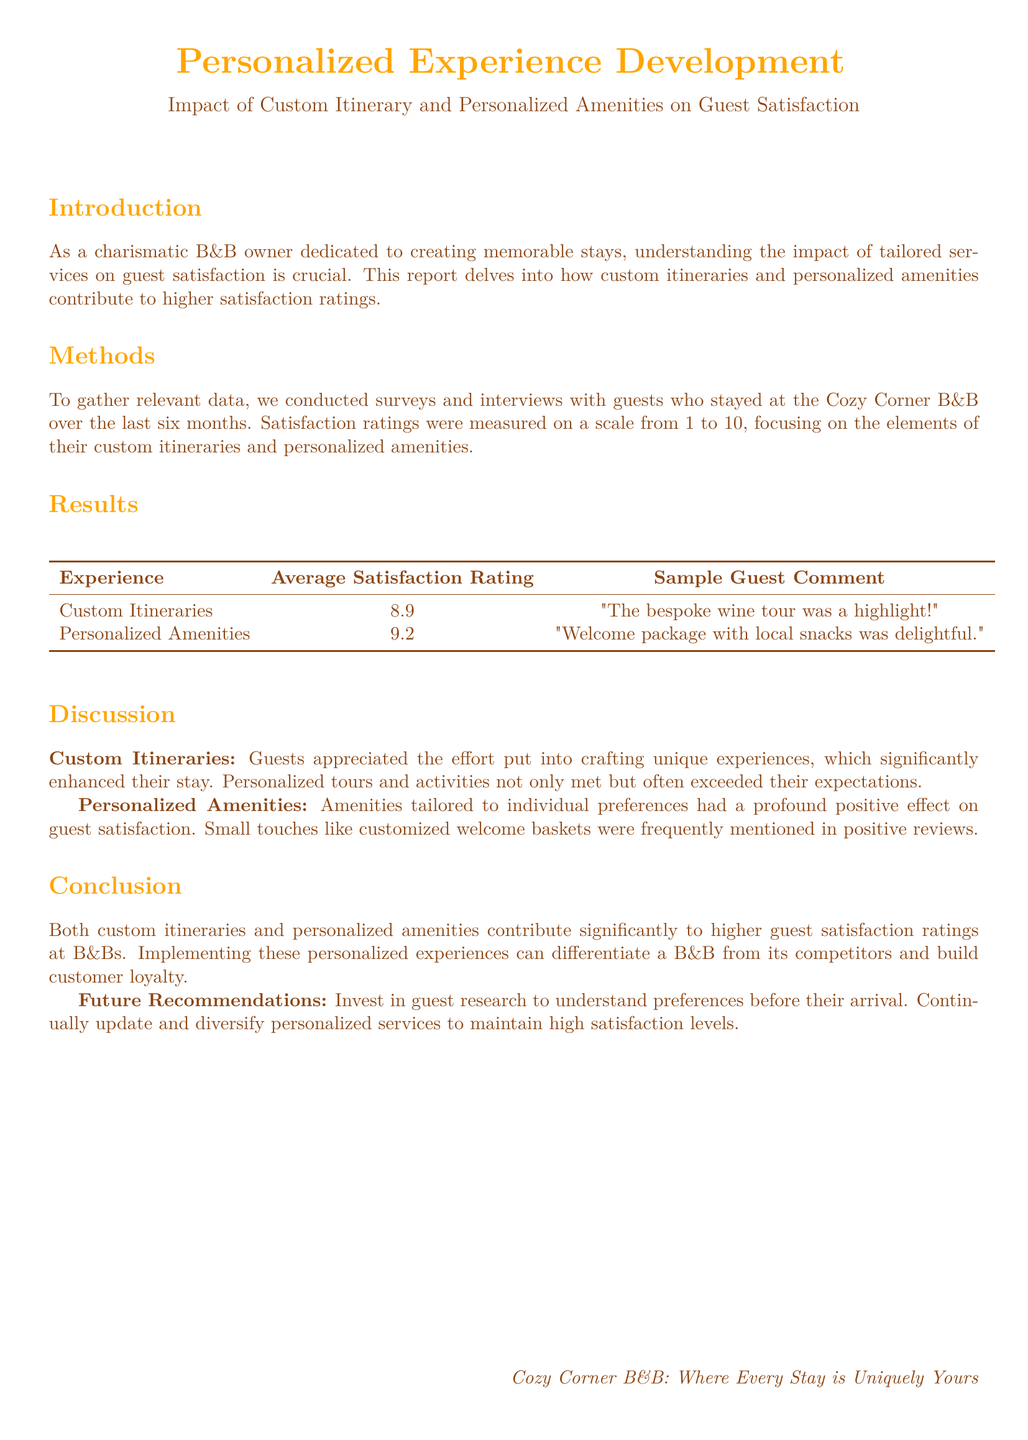What was the average satisfaction rating for custom itineraries? The average satisfaction rating for custom itineraries is found in the results section of the document.
Answer: 8.9 What is a sample guest comment regarding personalized amenities? The sample guest comment for personalized amenities is provided in the results section.
Answer: "Welcome package with local snacks was delightful." What does the introduction emphasize as crucial for the B&B owner? The introduction section highlights the importance of understanding the impact of tailored services on guest satisfaction.
Answer: Tailored services What is the highest average satisfaction rating mentioned in the report? The report presents average satisfaction ratings, and the highest one can be identified in the results section.
Answer: 9.2 What key aspect differentiates a B&B from competitors according to the conclusion? The conclusion states that implementing personalized experiences can set a B&B apart, which is noted in the last sentences.
Answer: Personalized experiences How are guest satisfaction ratings measured in this study? The methods section describes the scale used to measure guest satisfaction ratings.
Answer: 1 to 10 What does the report suggest for future recommendations? Future recommendations are outlined in the conclusion, focusing on guest research and maintaining services.
Answer: Invest in guest research Which section discusses the effects of personalized amenities? The discussion section directly addresses the impact of personalized amenities on guest satisfaction.
Answer: Discussion What is the primary focus of this lab report? The title and introduction provide a clear idea of the main focus of the report.
Answer: Guest satisfaction ratings 